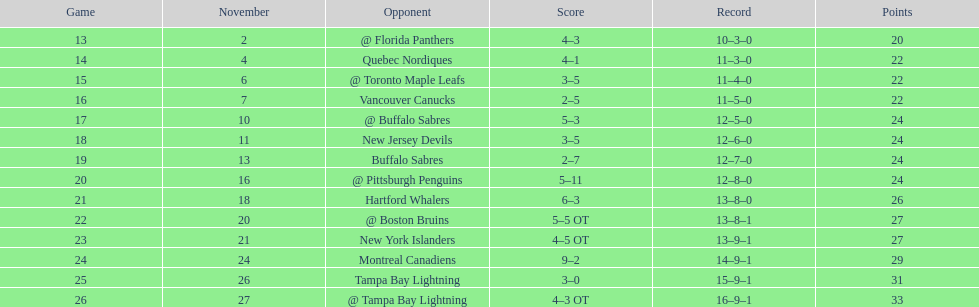What was the total count of victories for the philadelphia flyers? 35. 